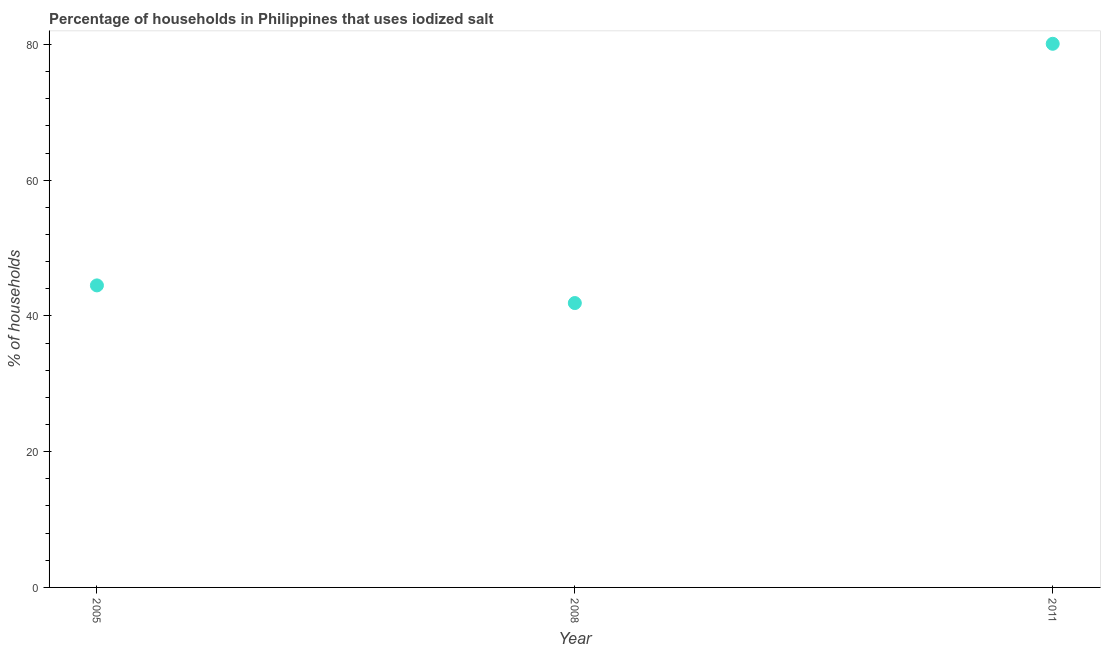What is the percentage of households where iodized salt is consumed in 2005?
Make the answer very short. 44.5. Across all years, what is the maximum percentage of households where iodized salt is consumed?
Your answer should be very brief. 80.1. Across all years, what is the minimum percentage of households where iodized salt is consumed?
Keep it short and to the point. 41.9. What is the sum of the percentage of households where iodized salt is consumed?
Your answer should be very brief. 166.5. What is the difference between the percentage of households where iodized salt is consumed in 2008 and 2011?
Give a very brief answer. -38.2. What is the average percentage of households where iodized salt is consumed per year?
Make the answer very short. 55.5. What is the median percentage of households where iodized salt is consumed?
Your answer should be compact. 44.5. What is the ratio of the percentage of households where iodized salt is consumed in 2005 to that in 2008?
Provide a short and direct response. 1.06. Is the percentage of households where iodized salt is consumed in 2008 less than that in 2011?
Provide a short and direct response. Yes. Is the difference between the percentage of households where iodized salt is consumed in 2008 and 2011 greater than the difference between any two years?
Provide a short and direct response. Yes. What is the difference between the highest and the second highest percentage of households where iodized salt is consumed?
Offer a very short reply. 35.6. What is the difference between the highest and the lowest percentage of households where iodized salt is consumed?
Make the answer very short. 38.2. Does the percentage of households where iodized salt is consumed monotonically increase over the years?
Your answer should be very brief. No. How many years are there in the graph?
Offer a very short reply. 3. What is the title of the graph?
Give a very brief answer. Percentage of households in Philippines that uses iodized salt. What is the label or title of the Y-axis?
Provide a short and direct response. % of households. What is the % of households in 2005?
Your response must be concise. 44.5. What is the % of households in 2008?
Your response must be concise. 41.9. What is the % of households in 2011?
Ensure brevity in your answer.  80.1. What is the difference between the % of households in 2005 and 2008?
Make the answer very short. 2.6. What is the difference between the % of households in 2005 and 2011?
Provide a short and direct response. -35.6. What is the difference between the % of households in 2008 and 2011?
Your answer should be compact. -38.2. What is the ratio of the % of households in 2005 to that in 2008?
Provide a short and direct response. 1.06. What is the ratio of the % of households in 2005 to that in 2011?
Your answer should be very brief. 0.56. What is the ratio of the % of households in 2008 to that in 2011?
Ensure brevity in your answer.  0.52. 